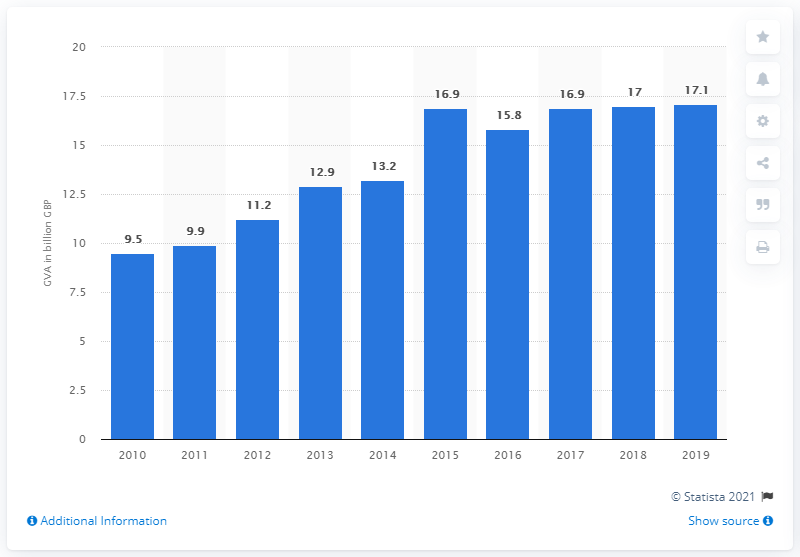Mention a couple of crucial points in this snapshot. The gross value added of the advertising and marketing industry in the UK in 2019 was £17.1 billion. 